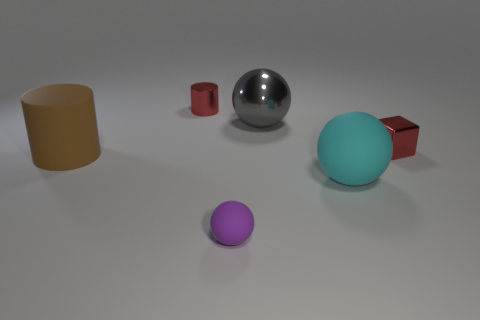What material is the tiny thing that is both behind the big cyan matte object and in front of the red shiny cylinder?
Your response must be concise. Metal. Do the block and the gray metallic object have the same size?
Offer a terse response. No. There is a brown thing behind the sphere on the right side of the large shiny ball; what size is it?
Offer a very short reply. Large. How many things are in front of the small cylinder and to the left of the tiny purple object?
Give a very brief answer. 1. Are there any blocks that are right of the small thing in front of the cyan sphere that is right of the tiny rubber thing?
Provide a succinct answer. Yes. There is a matte thing that is the same size as the brown rubber cylinder; what is its shape?
Your response must be concise. Sphere. Are there any large metallic objects of the same color as the big cylinder?
Provide a succinct answer. No. Do the big cyan rubber thing and the purple rubber object have the same shape?
Provide a succinct answer. Yes. What number of small objects are either red matte spheres or brown rubber cylinders?
Provide a succinct answer. 0. What color is the small sphere that is made of the same material as the cyan object?
Provide a succinct answer. Purple. 